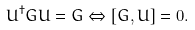Convert formula to latex. <formula><loc_0><loc_0><loc_500><loc_500>U ^ { \dagger } G U = G \Leftrightarrow [ G , U ] = 0 .</formula> 